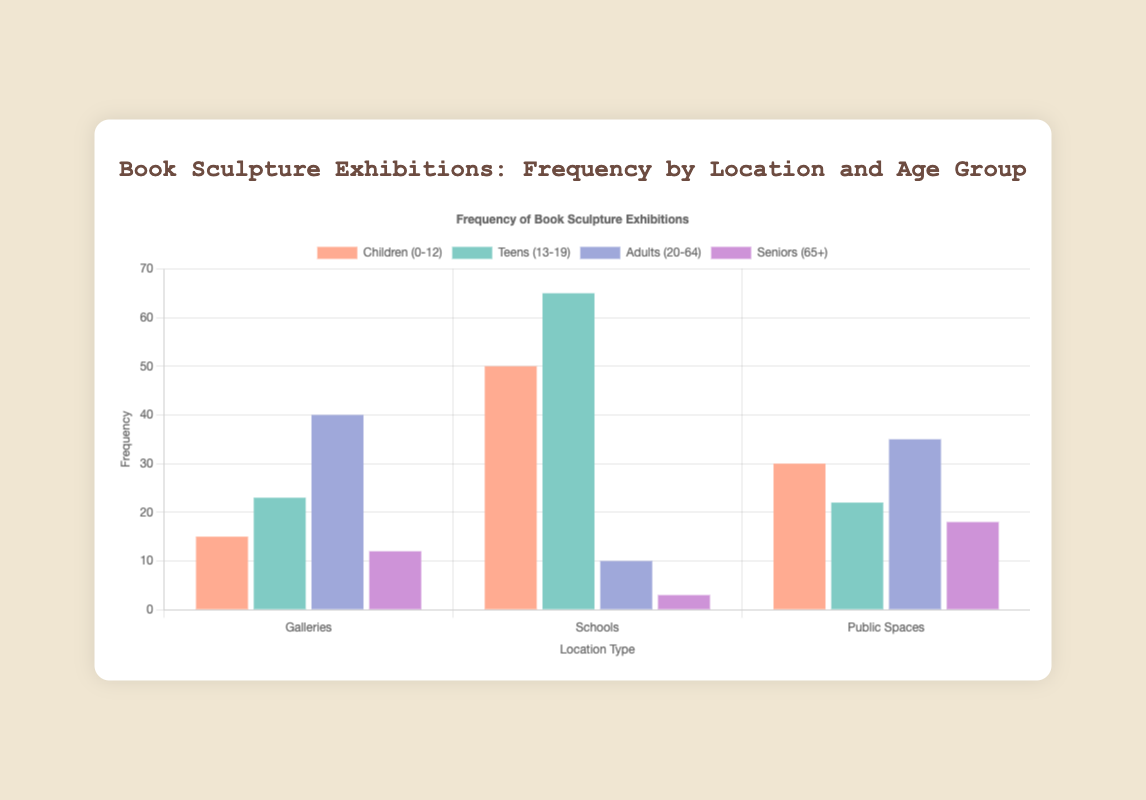Which location type has the highest frequency of exhibitions for children (0-12)? Check the heights of the bars corresponding to children (0-12). Schools have the highest bar (frequency 50).
Answer: Schools What is the total frequency of exhibitions for seniors (65+) across all location types? Sum the frequencies for seniors (65+) in all location types: Galleries (12) + Schools (3) + Public Spaces (18). 12 + 3 + 18 = 33.
Answer: 33 Which age group has the least frequency of exhibitions in schools? Look at the bars representing schools and find the one with the smallest height. Adults (20-64) have the frequency of 10, which is the least.
Answer: Adults (20-64) How does the frequency of exhibitions for teens (13-19) in galleries compare to that in public spaces? Compare the heights of the bars for teens (13-19) in galleries (23) and in public spaces (22). 23 is greater than 22, so the frequency is higher in galleries.
Answer: Higher in galleries What is the combined frequency of exhibitions in public spaces for children (0-12) and adults (20-64)? Sum the frequencies for children (0-12) and adults (20-64) in public spaces: Children (30) + Adults (35). 30 + 35 = 65.
Answer: 65 Which location type has the highest overall frequency of exhibitions? Sum the frequencies of all age groups for each location type and compare them. Galleries: 15 + 23 + 40 + 12 = 90, Schools: 50 + 65 + 10 + 3 = 128, Public Spaces: 30 + 22 + 35 + 18 = 105. Schools have the highest overall frequency (128).
Answer: Schools What is the average frequency of exhibitions for adults (20-64) across all location types? Calculate the average: Sum the frequencies for adults (20-64) in all location types: Galleries (40) + Schools (10) + Public Spaces (35). Sum: 40 + 10 + 35 = 85. Then find the average: 85 / 3 = 28.33.
Answer: 28.33 In which location type is the difference between the frequency of exhibitions for children (0-12) and teens (13-19) the largest? Calculate the differences for each location: Galleries 23 - 15 = 8, Schools 65 - 50 = 15, Public Spaces 22 - 30 = 8. The largest difference is in Schools (15).
Answer: Schools What is the overall frequency of exhibitions for all age groups in galleries? Sum the frequencies for all age groups in galleries: Children (0-12) (15) + Teens (13-19) (23) + Adults (20-64) (40) + Seniors (65+) (12). 15 + 23 + 40 + 12 = 90
Answer: 90 Which age group has the lowest frequency of exhibitions in public spaces? Look at the bars representing public spaces and find the one with the smallest height. Teens (13-19) have the frequency of 22, which is the lowest.
Answer: Teens (13-19) 